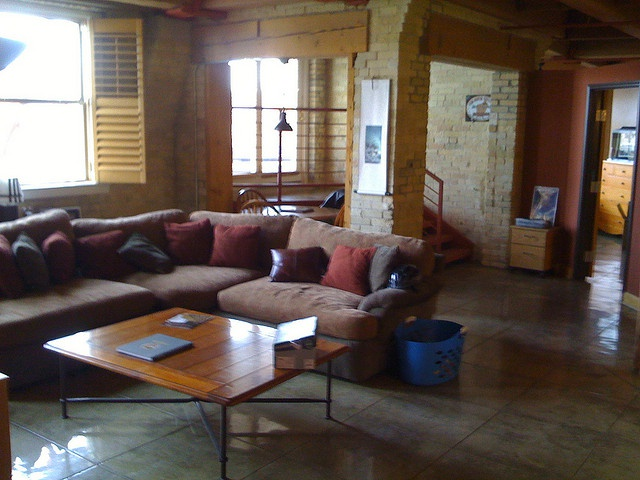Describe the objects in this image and their specific colors. I can see couch in darkgray, black, gray, and maroon tones, dining table in darkgray, black, maroon, and brown tones, book in darkgray, gray, and black tones, book in darkgray, white, black, lightblue, and gray tones, and dining table in darkgray, gray, maroon, white, and black tones in this image. 